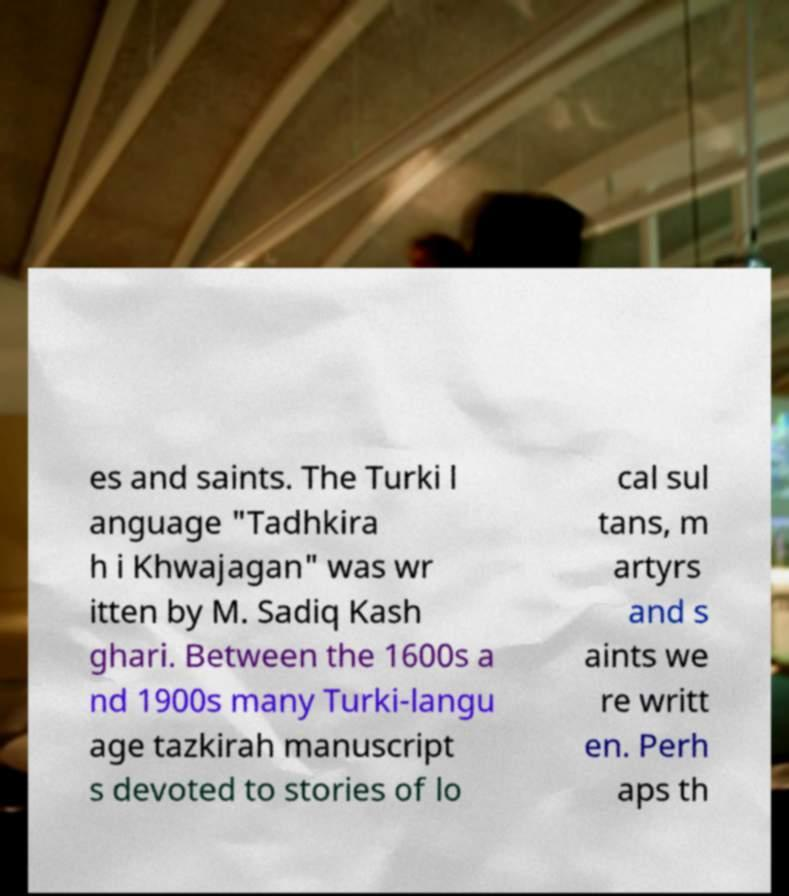There's text embedded in this image that I need extracted. Can you transcribe it verbatim? es and saints. The Turki l anguage "Tadhkira h i Khwajagan" was wr itten by M. Sadiq Kash ghari. Between the 1600s a nd 1900s many Turki-langu age tazkirah manuscript s devoted to stories of lo cal sul tans, m artyrs and s aints we re writt en. Perh aps th 